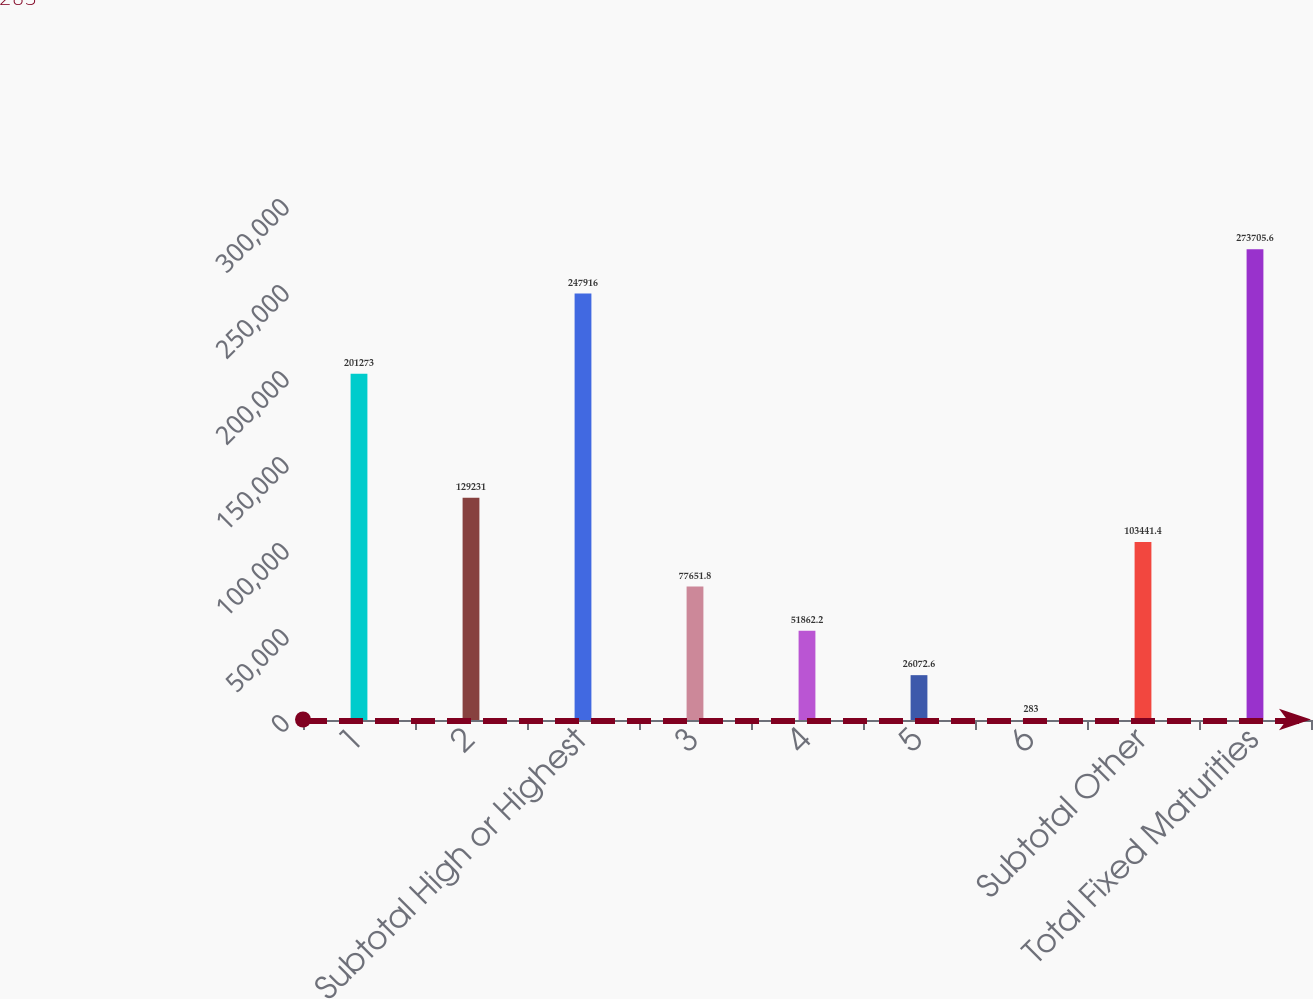<chart> <loc_0><loc_0><loc_500><loc_500><bar_chart><fcel>1<fcel>2<fcel>Subtotal High or Highest<fcel>3<fcel>4<fcel>5<fcel>6<fcel>Subtotal Other<fcel>Total Fixed Maturities<nl><fcel>201273<fcel>129231<fcel>247916<fcel>77651.8<fcel>51862.2<fcel>26072.6<fcel>283<fcel>103441<fcel>273706<nl></chart> 